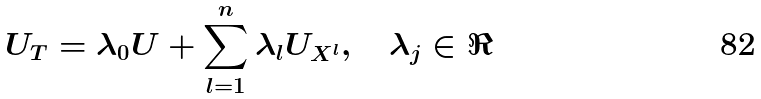Convert formula to latex. <formula><loc_0><loc_0><loc_500><loc_500>U _ { T } = \lambda _ { 0 } U + \sum _ { l = 1 } ^ { n } \lambda _ { l } U _ { X ^ { l } } , \quad \lambda _ { j } \in \Re</formula> 